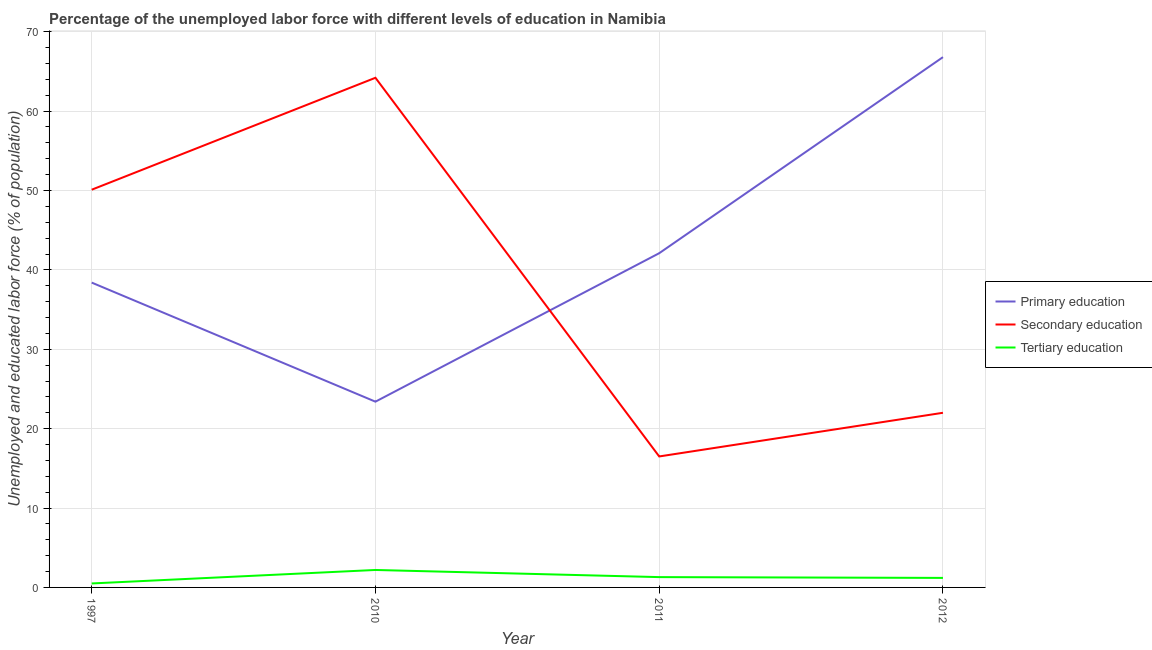How many different coloured lines are there?
Ensure brevity in your answer.  3. Does the line corresponding to percentage of labor force who received secondary education intersect with the line corresponding to percentage of labor force who received primary education?
Give a very brief answer. Yes. What is the percentage of labor force who received primary education in 2012?
Ensure brevity in your answer.  66.8. Across all years, what is the maximum percentage of labor force who received secondary education?
Provide a succinct answer. 64.2. In which year was the percentage of labor force who received tertiary education maximum?
Your answer should be compact. 2010. In which year was the percentage of labor force who received tertiary education minimum?
Offer a very short reply. 1997. What is the total percentage of labor force who received primary education in the graph?
Offer a terse response. 170.7. What is the difference between the percentage of labor force who received secondary education in 1997 and that in 2012?
Your answer should be very brief. 28.1. What is the difference between the percentage of labor force who received primary education in 2010 and the percentage of labor force who received tertiary education in 2012?
Make the answer very short. 22.2. What is the average percentage of labor force who received tertiary education per year?
Your answer should be very brief. 1.3. In the year 2010, what is the difference between the percentage of labor force who received primary education and percentage of labor force who received tertiary education?
Provide a succinct answer. 21.2. What is the ratio of the percentage of labor force who received tertiary education in 1997 to that in 2012?
Keep it short and to the point. 0.42. Is the percentage of labor force who received primary education in 2010 less than that in 2012?
Give a very brief answer. Yes. What is the difference between the highest and the second highest percentage of labor force who received primary education?
Keep it short and to the point. 24.7. What is the difference between the highest and the lowest percentage of labor force who received tertiary education?
Provide a succinct answer. 1.7. Is the sum of the percentage of labor force who received primary education in 2010 and 2011 greater than the maximum percentage of labor force who received secondary education across all years?
Offer a very short reply. Yes. Does the percentage of labor force who received secondary education monotonically increase over the years?
Offer a terse response. No. Is the percentage of labor force who received tertiary education strictly greater than the percentage of labor force who received primary education over the years?
Give a very brief answer. No. Are the values on the major ticks of Y-axis written in scientific E-notation?
Your answer should be very brief. No. Does the graph contain any zero values?
Offer a very short reply. No. What is the title of the graph?
Keep it short and to the point. Percentage of the unemployed labor force with different levels of education in Namibia. Does "Renewable sources" appear as one of the legend labels in the graph?
Provide a short and direct response. No. What is the label or title of the Y-axis?
Provide a short and direct response. Unemployed and educated labor force (% of population). What is the Unemployed and educated labor force (% of population) in Primary education in 1997?
Make the answer very short. 38.4. What is the Unemployed and educated labor force (% of population) in Secondary education in 1997?
Offer a very short reply. 50.1. What is the Unemployed and educated labor force (% of population) in Tertiary education in 1997?
Ensure brevity in your answer.  0.5. What is the Unemployed and educated labor force (% of population) in Primary education in 2010?
Keep it short and to the point. 23.4. What is the Unemployed and educated labor force (% of population) of Secondary education in 2010?
Keep it short and to the point. 64.2. What is the Unemployed and educated labor force (% of population) of Tertiary education in 2010?
Make the answer very short. 2.2. What is the Unemployed and educated labor force (% of population) in Primary education in 2011?
Give a very brief answer. 42.1. What is the Unemployed and educated labor force (% of population) in Tertiary education in 2011?
Offer a very short reply. 1.3. What is the Unemployed and educated labor force (% of population) of Primary education in 2012?
Give a very brief answer. 66.8. What is the Unemployed and educated labor force (% of population) of Tertiary education in 2012?
Your response must be concise. 1.2. Across all years, what is the maximum Unemployed and educated labor force (% of population) of Primary education?
Keep it short and to the point. 66.8. Across all years, what is the maximum Unemployed and educated labor force (% of population) of Secondary education?
Make the answer very short. 64.2. Across all years, what is the maximum Unemployed and educated labor force (% of population) of Tertiary education?
Provide a succinct answer. 2.2. Across all years, what is the minimum Unemployed and educated labor force (% of population) of Primary education?
Keep it short and to the point. 23.4. Across all years, what is the minimum Unemployed and educated labor force (% of population) in Secondary education?
Offer a terse response. 16.5. What is the total Unemployed and educated labor force (% of population) of Primary education in the graph?
Offer a very short reply. 170.7. What is the total Unemployed and educated labor force (% of population) in Secondary education in the graph?
Provide a succinct answer. 152.8. What is the total Unemployed and educated labor force (% of population) in Tertiary education in the graph?
Ensure brevity in your answer.  5.2. What is the difference between the Unemployed and educated labor force (% of population) in Primary education in 1997 and that in 2010?
Ensure brevity in your answer.  15. What is the difference between the Unemployed and educated labor force (% of population) in Secondary education in 1997 and that in 2010?
Your answer should be very brief. -14.1. What is the difference between the Unemployed and educated labor force (% of population) of Tertiary education in 1997 and that in 2010?
Keep it short and to the point. -1.7. What is the difference between the Unemployed and educated labor force (% of population) of Primary education in 1997 and that in 2011?
Your answer should be compact. -3.7. What is the difference between the Unemployed and educated labor force (% of population) in Secondary education in 1997 and that in 2011?
Offer a very short reply. 33.6. What is the difference between the Unemployed and educated labor force (% of population) of Tertiary education in 1997 and that in 2011?
Your answer should be very brief. -0.8. What is the difference between the Unemployed and educated labor force (% of population) of Primary education in 1997 and that in 2012?
Your response must be concise. -28.4. What is the difference between the Unemployed and educated labor force (% of population) of Secondary education in 1997 and that in 2012?
Offer a very short reply. 28.1. What is the difference between the Unemployed and educated labor force (% of population) in Primary education in 2010 and that in 2011?
Ensure brevity in your answer.  -18.7. What is the difference between the Unemployed and educated labor force (% of population) of Secondary education in 2010 and that in 2011?
Your answer should be very brief. 47.7. What is the difference between the Unemployed and educated labor force (% of population) of Tertiary education in 2010 and that in 2011?
Make the answer very short. 0.9. What is the difference between the Unemployed and educated labor force (% of population) of Primary education in 2010 and that in 2012?
Offer a very short reply. -43.4. What is the difference between the Unemployed and educated labor force (% of population) of Secondary education in 2010 and that in 2012?
Keep it short and to the point. 42.2. What is the difference between the Unemployed and educated labor force (% of population) in Tertiary education in 2010 and that in 2012?
Offer a very short reply. 1. What is the difference between the Unemployed and educated labor force (% of population) in Primary education in 2011 and that in 2012?
Your response must be concise. -24.7. What is the difference between the Unemployed and educated labor force (% of population) in Tertiary education in 2011 and that in 2012?
Provide a short and direct response. 0.1. What is the difference between the Unemployed and educated labor force (% of population) of Primary education in 1997 and the Unemployed and educated labor force (% of population) of Secondary education in 2010?
Your answer should be compact. -25.8. What is the difference between the Unemployed and educated labor force (% of population) in Primary education in 1997 and the Unemployed and educated labor force (% of population) in Tertiary education in 2010?
Make the answer very short. 36.2. What is the difference between the Unemployed and educated labor force (% of population) in Secondary education in 1997 and the Unemployed and educated labor force (% of population) in Tertiary education in 2010?
Your response must be concise. 47.9. What is the difference between the Unemployed and educated labor force (% of population) of Primary education in 1997 and the Unemployed and educated labor force (% of population) of Secondary education in 2011?
Your response must be concise. 21.9. What is the difference between the Unemployed and educated labor force (% of population) of Primary education in 1997 and the Unemployed and educated labor force (% of population) of Tertiary education in 2011?
Your answer should be compact. 37.1. What is the difference between the Unemployed and educated labor force (% of population) in Secondary education in 1997 and the Unemployed and educated labor force (% of population) in Tertiary education in 2011?
Make the answer very short. 48.8. What is the difference between the Unemployed and educated labor force (% of population) in Primary education in 1997 and the Unemployed and educated labor force (% of population) in Secondary education in 2012?
Give a very brief answer. 16.4. What is the difference between the Unemployed and educated labor force (% of population) in Primary education in 1997 and the Unemployed and educated labor force (% of population) in Tertiary education in 2012?
Your answer should be very brief. 37.2. What is the difference between the Unemployed and educated labor force (% of population) of Secondary education in 1997 and the Unemployed and educated labor force (% of population) of Tertiary education in 2012?
Give a very brief answer. 48.9. What is the difference between the Unemployed and educated labor force (% of population) of Primary education in 2010 and the Unemployed and educated labor force (% of population) of Secondary education in 2011?
Your answer should be compact. 6.9. What is the difference between the Unemployed and educated labor force (% of population) in Primary education in 2010 and the Unemployed and educated labor force (% of population) in Tertiary education in 2011?
Offer a terse response. 22.1. What is the difference between the Unemployed and educated labor force (% of population) in Secondary education in 2010 and the Unemployed and educated labor force (% of population) in Tertiary education in 2011?
Provide a succinct answer. 62.9. What is the difference between the Unemployed and educated labor force (% of population) in Primary education in 2010 and the Unemployed and educated labor force (% of population) in Secondary education in 2012?
Offer a terse response. 1.4. What is the difference between the Unemployed and educated labor force (% of population) of Primary education in 2010 and the Unemployed and educated labor force (% of population) of Tertiary education in 2012?
Keep it short and to the point. 22.2. What is the difference between the Unemployed and educated labor force (% of population) in Secondary education in 2010 and the Unemployed and educated labor force (% of population) in Tertiary education in 2012?
Make the answer very short. 63. What is the difference between the Unemployed and educated labor force (% of population) of Primary education in 2011 and the Unemployed and educated labor force (% of population) of Secondary education in 2012?
Make the answer very short. 20.1. What is the difference between the Unemployed and educated labor force (% of population) in Primary education in 2011 and the Unemployed and educated labor force (% of population) in Tertiary education in 2012?
Your answer should be compact. 40.9. What is the difference between the Unemployed and educated labor force (% of population) in Secondary education in 2011 and the Unemployed and educated labor force (% of population) in Tertiary education in 2012?
Make the answer very short. 15.3. What is the average Unemployed and educated labor force (% of population) of Primary education per year?
Ensure brevity in your answer.  42.67. What is the average Unemployed and educated labor force (% of population) of Secondary education per year?
Your answer should be very brief. 38.2. What is the average Unemployed and educated labor force (% of population) of Tertiary education per year?
Ensure brevity in your answer.  1.3. In the year 1997, what is the difference between the Unemployed and educated labor force (% of population) of Primary education and Unemployed and educated labor force (% of population) of Tertiary education?
Make the answer very short. 37.9. In the year 1997, what is the difference between the Unemployed and educated labor force (% of population) of Secondary education and Unemployed and educated labor force (% of population) of Tertiary education?
Your answer should be very brief. 49.6. In the year 2010, what is the difference between the Unemployed and educated labor force (% of population) of Primary education and Unemployed and educated labor force (% of population) of Secondary education?
Your response must be concise. -40.8. In the year 2010, what is the difference between the Unemployed and educated labor force (% of population) in Primary education and Unemployed and educated labor force (% of population) in Tertiary education?
Make the answer very short. 21.2. In the year 2011, what is the difference between the Unemployed and educated labor force (% of population) of Primary education and Unemployed and educated labor force (% of population) of Secondary education?
Your answer should be compact. 25.6. In the year 2011, what is the difference between the Unemployed and educated labor force (% of population) of Primary education and Unemployed and educated labor force (% of population) of Tertiary education?
Give a very brief answer. 40.8. In the year 2011, what is the difference between the Unemployed and educated labor force (% of population) of Secondary education and Unemployed and educated labor force (% of population) of Tertiary education?
Your answer should be very brief. 15.2. In the year 2012, what is the difference between the Unemployed and educated labor force (% of population) in Primary education and Unemployed and educated labor force (% of population) in Secondary education?
Your answer should be compact. 44.8. In the year 2012, what is the difference between the Unemployed and educated labor force (% of population) of Primary education and Unemployed and educated labor force (% of population) of Tertiary education?
Offer a terse response. 65.6. In the year 2012, what is the difference between the Unemployed and educated labor force (% of population) in Secondary education and Unemployed and educated labor force (% of population) in Tertiary education?
Offer a very short reply. 20.8. What is the ratio of the Unemployed and educated labor force (% of population) in Primary education in 1997 to that in 2010?
Your answer should be very brief. 1.64. What is the ratio of the Unemployed and educated labor force (% of population) in Secondary education in 1997 to that in 2010?
Your answer should be very brief. 0.78. What is the ratio of the Unemployed and educated labor force (% of population) in Tertiary education in 1997 to that in 2010?
Your answer should be compact. 0.23. What is the ratio of the Unemployed and educated labor force (% of population) in Primary education in 1997 to that in 2011?
Provide a succinct answer. 0.91. What is the ratio of the Unemployed and educated labor force (% of population) of Secondary education in 1997 to that in 2011?
Keep it short and to the point. 3.04. What is the ratio of the Unemployed and educated labor force (% of population) in Tertiary education in 1997 to that in 2011?
Ensure brevity in your answer.  0.38. What is the ratio of the Unemployed and educated labor force (% of population) of Primary education in 1997 to that in 2012?
Keep it short and to the point. 0.57. What is the ratio of the Unemployed and educated labor force (% of population) of Secondary education in 1997 to that in 2012?
Provide a short and direct response. 2.28. What is the ratio of the Unemployed and educated labor force (% of population) of Tertiary education in 1997 to that in 2012?
Provide a succinct answer. 0.42. What is the ratio of the Unemployed and educated labor force (% of population) of Primary education in 2010 to that in 2011?
Make the answer very short. 0.56. What is the ratio of the Unemployed and educated labor force (% of population) in Secondary education in 2010 to that in 2011?
Your answer should be compact. 3.89. What is the ratio of the Unemployed and educated labor force (% of population) in Tertiary education in 2010 to that in 2011?
Give a very brief answer. 1.69. What is the ratio of the Unemployed and educated labor force (% of population) of Primary education in 2010 to that in 2012?
Provide a short and direct response. 0.35. What is the ratio of the Unemployed and educated labor force (% of population) of Secondary education in 2010 to that in 2012?
Ensure brevity in your answer.  2.92. What is the ratio of the Unemployed and educated labor force (% of population) of Tertiary education in 2010 to that in 2012?
Your answer should be compact. 1.83. What is the ratio of the Unemployed and educated labor force (% of population) in Primary education in 2011 to that in 2012?
Your answer should be very brief. 0.63. What is the ratio of the Unemployed and educated labor force (% of population) in Secondary education in 2011 to that in 2012?
Offer a terse response. 0.75. What is the ratio of the Unemployed and educated labor force (% of population) in Tertiary education in 2011 to that in 2012?
Offer a terse response. 1.08. What is the difference between the highest and the second highest Unemployed and educated labor force (% of population) of Primary education?
Give a very brief answer. 24.7. What is the difference between the highest and the second highest Unemployed and educated labor force (% of population) of Secondary education?
Provide a succinct answer. 14.1. What is the difference between the highest and the lowest Unemployed and educated labor force (% of population) of Primary education?
Provide a succinct answer. 43.4. What is the difference between the highest and the lowest Unemployed and educated labor force (% of population) of Secondary education?
Keep it short and to the point. 47.7. What is the difference between the highest and the lowest Unemployed and educated labor force (% of population) of Tertiary education?
Your answer should be compact. 1.7. 